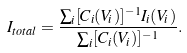Convert formula to latex. <formula><loc_0><loc_0><loc_500><loc_500>I _ { t o t a l } = \frac { \sum _ { i } [ C _ { i } ( V _ { i } ) ] ^ { - 1 } I _ { i } ( V _ { i } ) } { \sum _ { i } [ C _ { i } ( V _ { i } ) ] ^ { - 1 } } .</formula> 